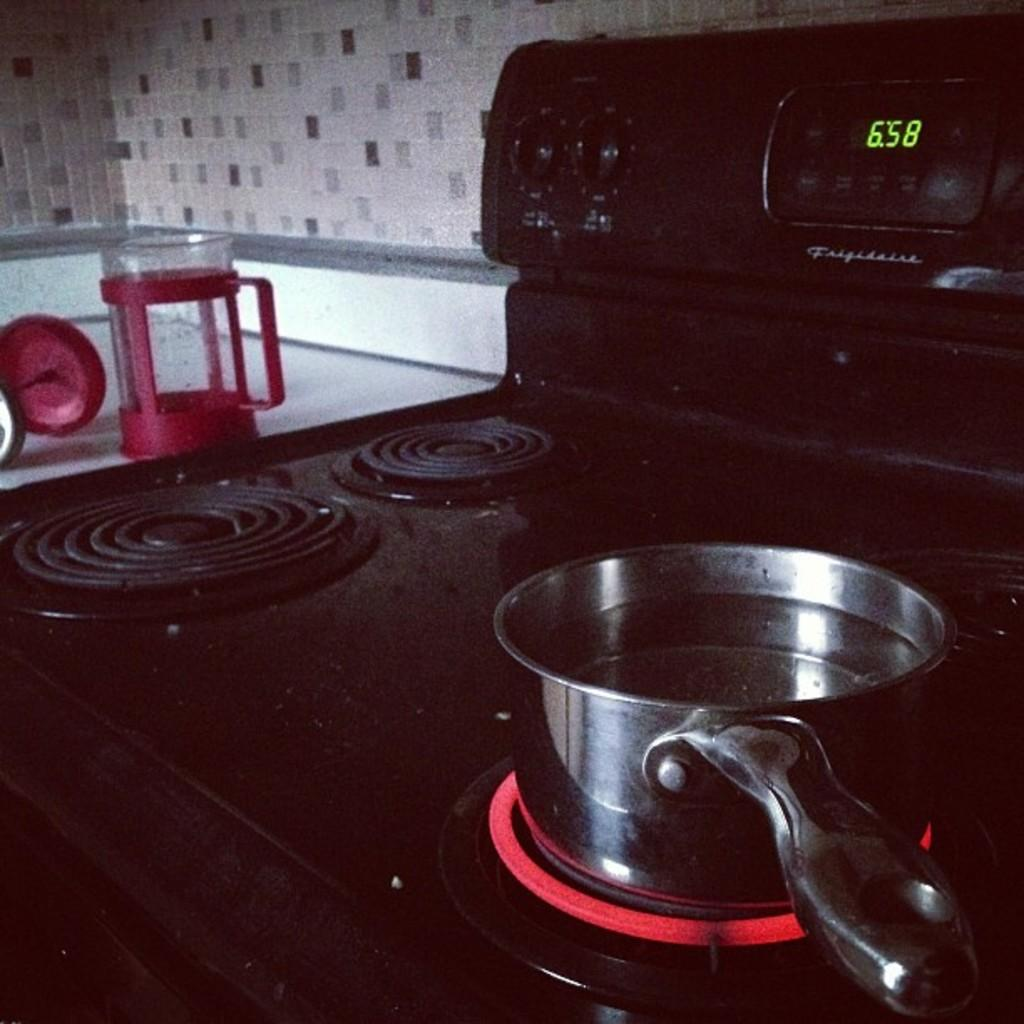<image>
Offer a succinct explanation of the picture presented. a pot warming on a hot stove burner by Frigidaire 